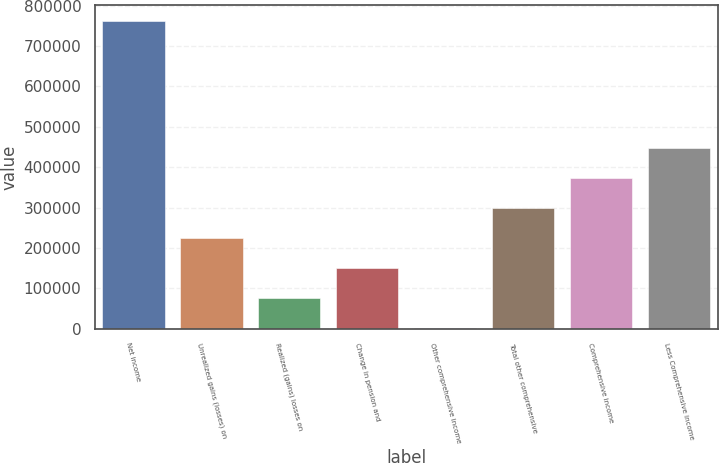Convert chart. <chart><loc_0><loc_0><loc_500><loc_500><bar_chart><fcel>Net income<fcel>Unrealized gains (losses) on<fcel>Realized (gains) losses on<fcel>Change in pension and<fcel>Other comprehensive income<fcel>Total other comprehensive<fcel>Comprehensive income<fcel>Less Comprehensive income<nl><fcel>762223<fcel>224103<fcel>75704.4<fcel>149904<fcel>1505<fcel>298303<fcel>372502<fcel>446701<nl></chart> 